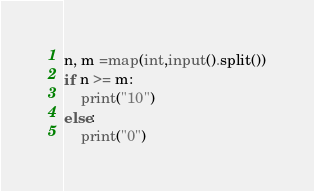<code> <loc_0><loc_0><loc_500><loc_500><_Python_>n, m =map(int,input().split())
if n >= m:
    print("10")
else:
    print("0")
</code> 